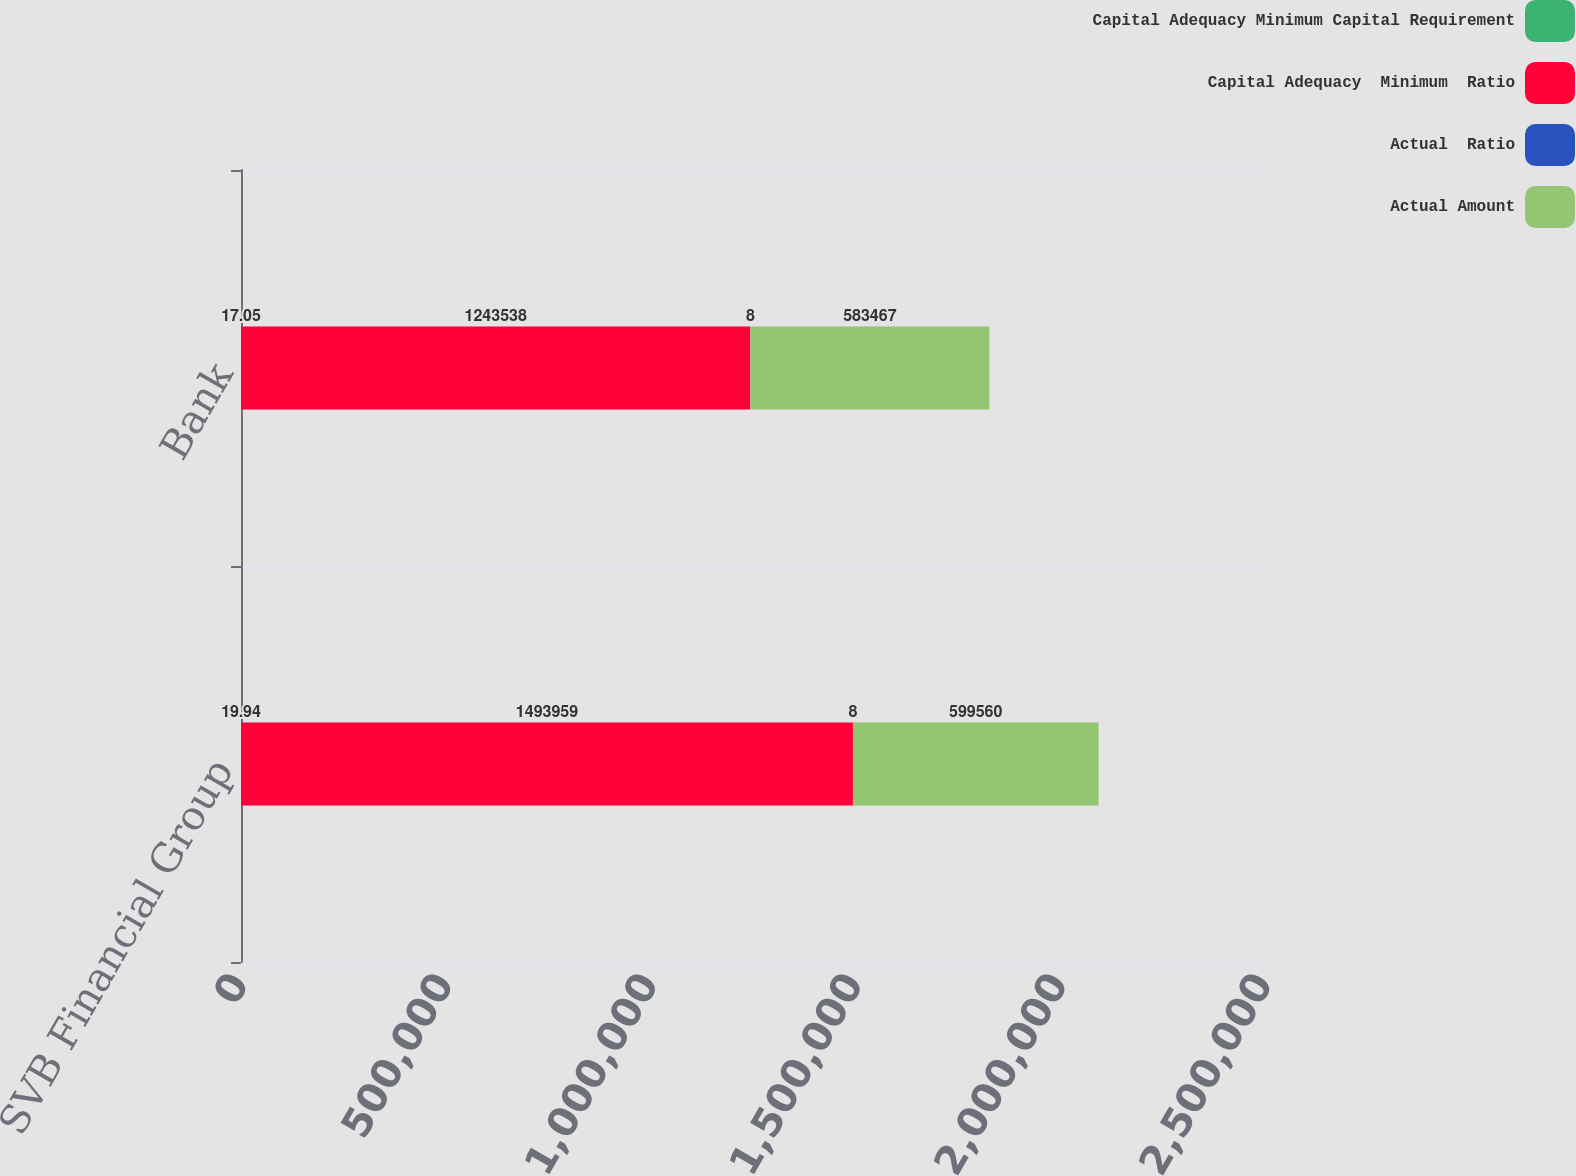Convert chart to OTSL. <chart><loc_0><loc_0><loc_500><loc_500><stacked_bar_chart><ecel><fcel>SVB Financial Group<fcel>Bank<nl><fcel>Capital Adequacy Minimum Capital Requirement<fcel>19.94<fcel>17.05<nl><fcel>Capital Adequacy  Minimum  Ratio<fcel>1.49396e+06<fcel>1.24354e+06<nl><fcel>Actual  Ratio<fcel>8<fcel>8<nl><fcel>Actual Amount<fcel>599560<fcel>583467<nl></chart> 